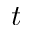Convert formula to latex. <formula><loc_0><loc_0><loc_500><loc_500>t</formula> 